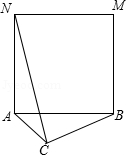First perform reasoning, then finally select the question from the choices in the following format: Answer: xxx.
Question: As shown in the figure, it is known that in triangle ABC, AC = 2.0, BC = 4.0, and AB is the side shape to make a square ABMN. If the degree of angle ACB changes and connects to CN, the maximum value of CN is ()
Choices:
A: 4√{2}
B: 6√{2}
C: 4+2√{2}
D: 2+4√{2} Solution: Since quadrilateral ABMN is a square, AB=AN and angle BAN=90°. 
Therefore, rotating triangle ACB counterclockwise 90° around point A results in triangle AC'N. 
By therefore,, angle CAC'=90°, AC'=AC=2, NC'=BC=4. 
Therefore, triangle ACC' is an isosceles right triangle, so CC' = √2*AC = 2√2. 
Since NC'+CC' ≥ NC (only when point C' is on NC, equality holds), when point C' is on NC, NC is maximal. 
In this case, NC = 4+2√2, so the maximum value of CN is 4+2√2. 
This implies that the correct answer is C.
Answer:C 